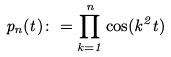Convert formula to latex. <formula><loc_0><loc_0><loc_500><loc_500>p _ { n } ( t ) \colon = \prod _ { k = 1 } ^ { n } \cos ( k ^ { 2 } t )</formula> 